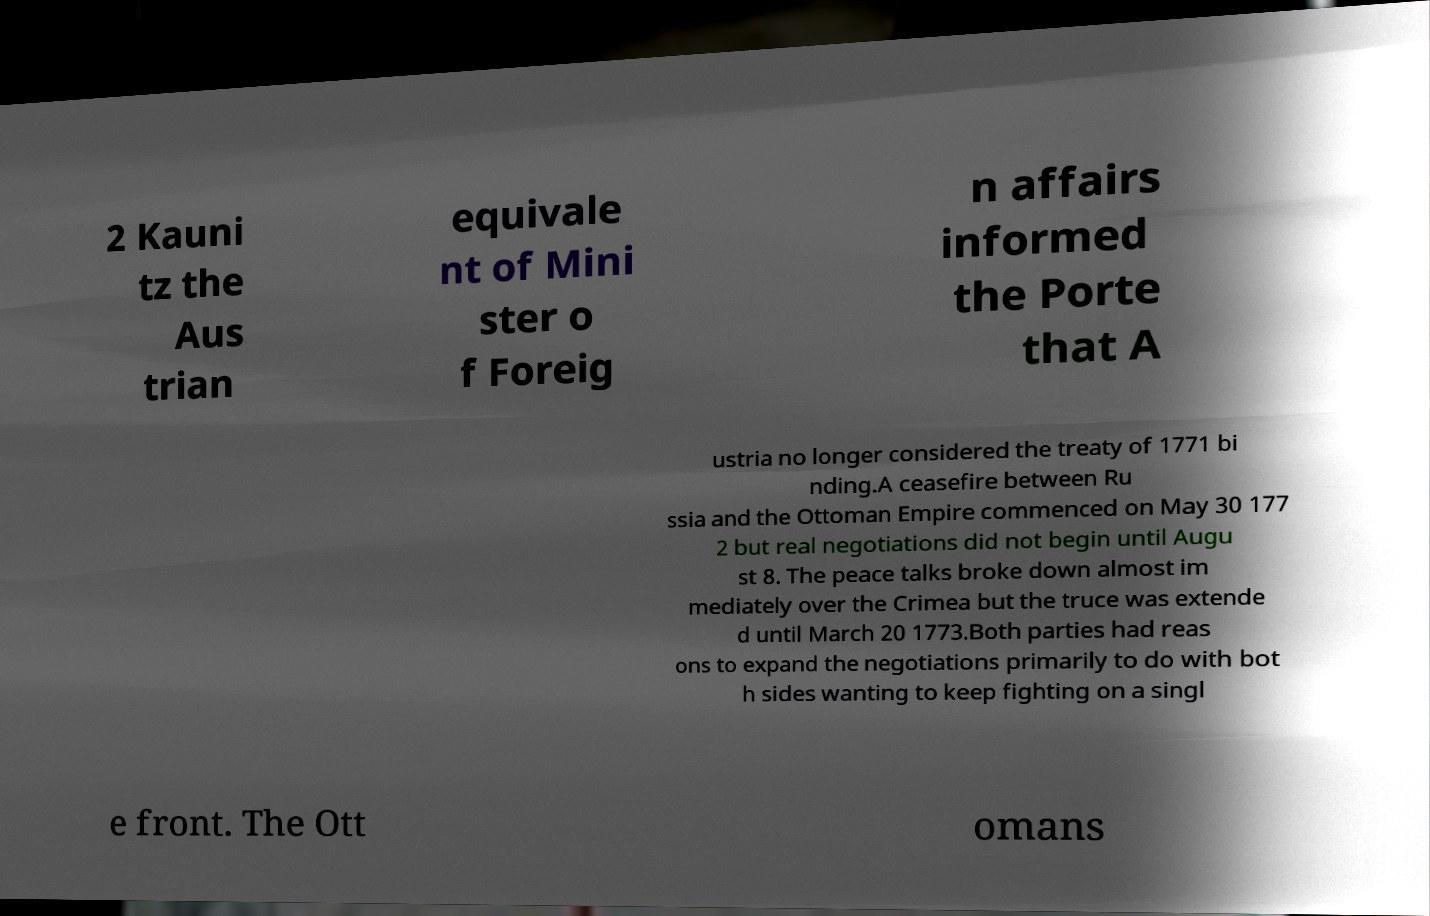Please identify and transcribe the text found in this image. 2 Kauni tz the Aus trian equivale nt of Mini ster o f Foreig n affairs informed the Porte that A ustria no longer considered the treaty of 1771 bi nding.A ceasefire between Ru ssia and the Ottoman Empire commenced on May 30 177 2 but real negotiations did not begin until Augu st 8. The peace talks broke down almost im mediately over the Crimea but the truce was extende d until March 20 1773.Both parties had reas ons to expand the negotiations primarily to do with bot h sides wanting to keep fighting on a singl e front. The Ott omans 